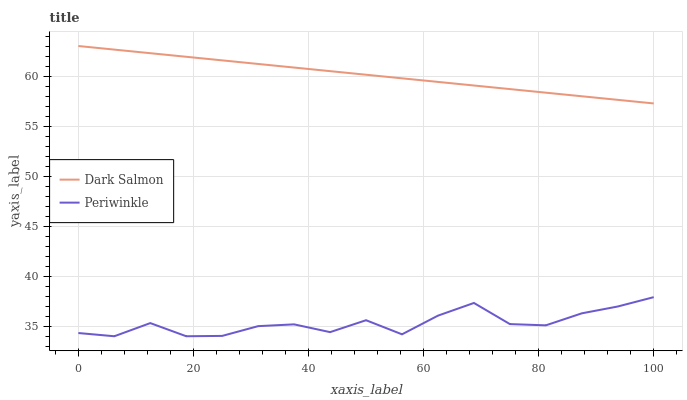Does Periwinkle have the minimum area under the curve?
Answer yes or no. Yes. Does Dark Salmon have the maximum area under the curve?
Answer yes or no. Yes. Does Dark Salmon have the minimum area under the curve?
Answer yes or no. No. Is Dark Salmon the smoothest?
Answer yes or no. Yes. Is Periwinkle the roughest?
Answer yes or no. Yes. Is Dark Salmon the roughest?
Answer yes or no. No. Does Dark Salmon have the lowest value?
Answer yes or no. No. Does Dark Salmon have the highest value?
Answer yes or no. Yes. Is Periwinkle less than Dark Salmon?
Answer yes or no. Yes. Is Dark Salmon greater than Periwinkle?
Answer yes or no. Yes. Does Periwinkle intersect Dark Salmon?
Answer yes or no. No. 